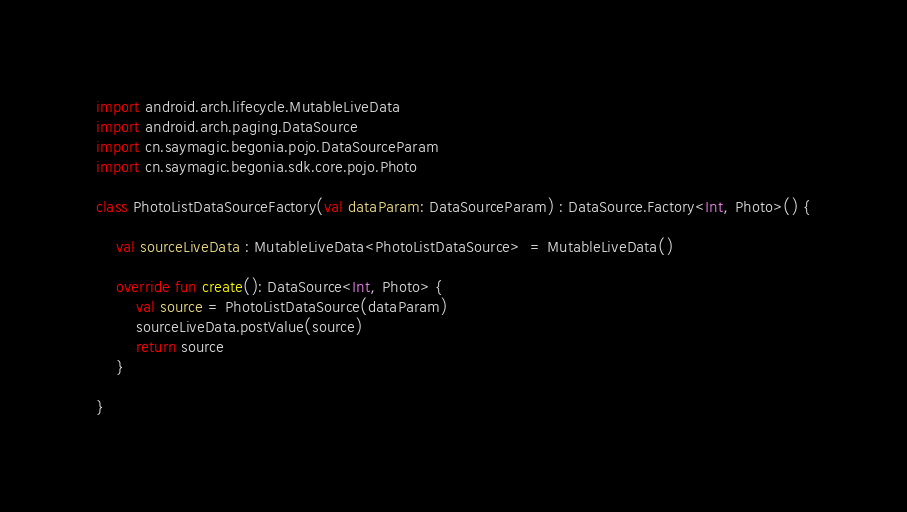<code> <loc_0><loc_0><loc_500><loc_500><_Kotlin_>import android.arch.lifecycle.MutableLiveData
import android.arch.paging.DataSource
import cn.saymagic.begonia.pojo.DataSourceParam
import cn.saymagic.begonia.sdk.core.pojo.Photo

class PhotoListDataSourceFactory(val dataParam: DataSourceParam) : DataSource.Factory<Int, Photo>() {

    val sourceLiveData : MutableLiveData<PhotoListDataSource>  = MutableLiveData()

    override fun create(): DataSource<Int, Photo> {
        val source = PhotoListDataSource(dataParam)
        sourceLiveData.postValue(source)
        return source
    }

}</code> 